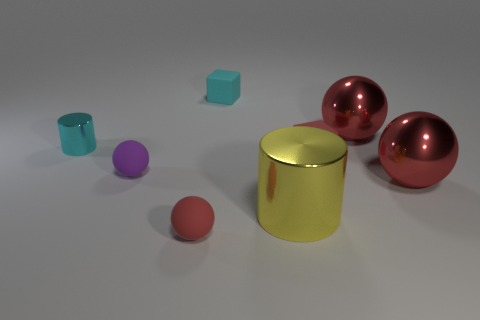How many objects are in the image, and can you describe their shapes? There are five objects in the image. Two of them are spheres, two are cylindrical—one large and one small, and the last one is a cube-shaped block. 